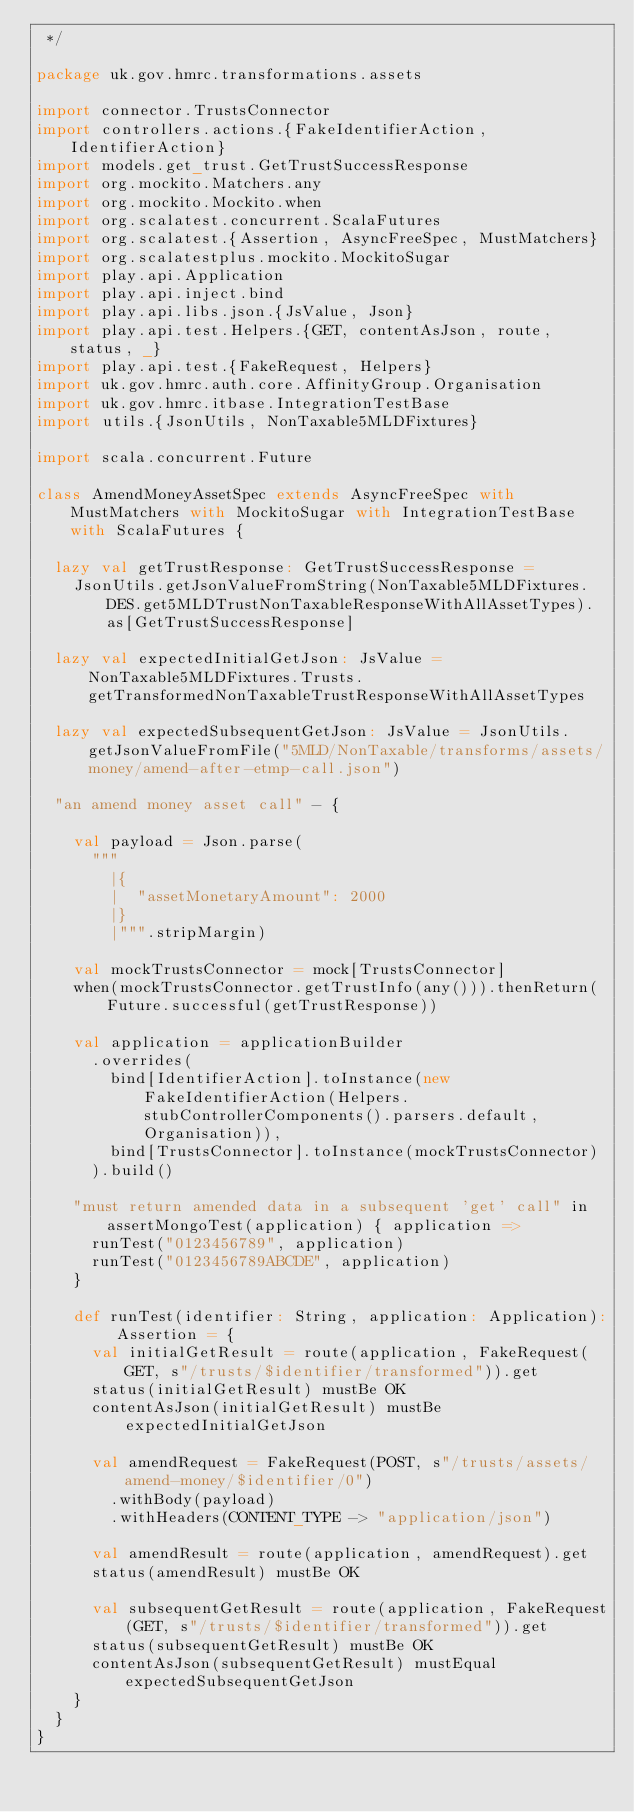Convert code to text. <code><loc_0><loc_0><loc_500><loc_500><_Scala_> */

package uk.gov.hmrc.transformations.assets

import connector.TrustsConnector
import controllers.actions.{FakeIdentifierAction, IdentifierAction}
import models.get_trust.GetTrustSuccessResponse
import org.mockito.Matchers.any
import org.mockito.Mockito.when
import org.scalatest.concurrent.ScalaFutures
import org.scalatest.{Assertion, AsyncFreeSpec, MustMatchers}
import org.scalatestplus.mockito.MockitoSugar
import play.api.Application
import play.api.inject.bind
import play.api.libs.json.{JsValue, Json}
import play.api.test.Helpers.{GET, contentAsJson, route, status, _}
import play.api.test.{FakeRequest, Helpers}
import uk.gov.hmrc.auth.core.AffinityGroup.Organisation
import uk.gov.hmrc.itbase.IntegrationTestBase
import utils.{JsonUtils, NonTaxable5MLDFixtures}

import scala.concurrent.Future

class AmendMoneyAssetSpec extends AsyncFreeSpec with MustMatchers with MockitoSugar with IntegrationTestBase with ScalaFutures {

  lazy val getTrustResponse: GetTrustSuccessResponse =
    JsonUtils.getJsonValueFromString(NonTaxable5MLDFixtures.DES.get5MLDTrustNonTaxableResponseWithAllAssetTypes).as[GetTrustSuccessResponse]

  lazy val expectedInitialGetJson: JsValue = NonTaxable5MLDFixtures.Trusts.getTransformedNonTaxableTrustResponseWithAllAssetTypes

  lazy val expectedSubsequentGetJson: JsValue = JsonUtils.getJsonValueFromFile("5MLD/NonTaxable/transforms/assets/money/amend-after-etmp-call.json")

  "an amend money asset call" - {

    val payload = Json.parse(
      """
        |{
        |  "assetMonetaryAmount": 2000
        |}
        |""".stripMargin)

    val mockTrustsConnector = mock[TrustsConnector]
    when(mockTrustsConnector.getTrustInfo(any())).thenReturn(Future.successful(getTrustResponse))

    val application = applicationBuilder
      .overrides(
        bind[IdentifierAction].toInstance(new FakeIdentifierAction(Helpers.stubControllerComponents().parsers.default, Organisation)),
        bind[TrustsConnector].toInstance(mockTrustsConnector)
      ).build()

    "must return amended data in a subsequent 'get' call" in assertMongoTest(application) { application =>
      runTest("0123456789", application)
      runTest("0123456789ABCDE", application)
    }

    def runTest(identifier: String, application: Application): Assertion = {
      val initialGetResult = route(application, FakeRequest(GET, s"/trusts/$identifier/transformed")).get
      status(initialGetResult) mustBe OK
      contentAsJson(initialGetResult) mustBe expectedInitialGetJson

      val amendRequest = FakeRequest(POST, s"/trusts/assets/amend-money/$identifier/0")
        .withBody(payload)
        .withHeaders(CONTENT_TYPE -> "application/json")

      val amendResult = route(application, amendRequest).get
      status(amendResult) mustBe OK

      val subsequentGetResult = route(application, FakeRequest(GET, s"/trusts/$identifier/transformed")).get
      status(subsequentGetResult) mustBe OK
      contentAsJson(subsequentGetResult) mustEqual expectedSubsequentGetJson
    }
  }
}
</code> 